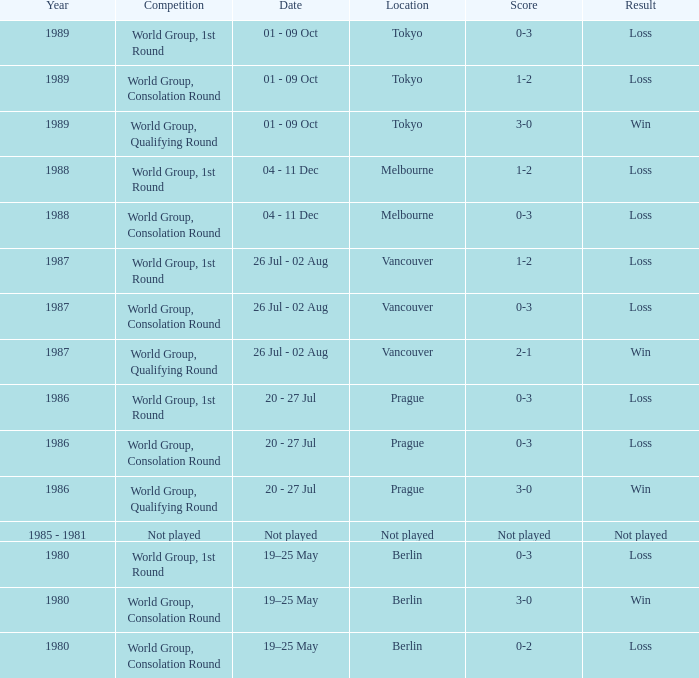What is the year when the date is not played? 1985 - 1981. 